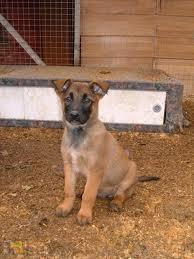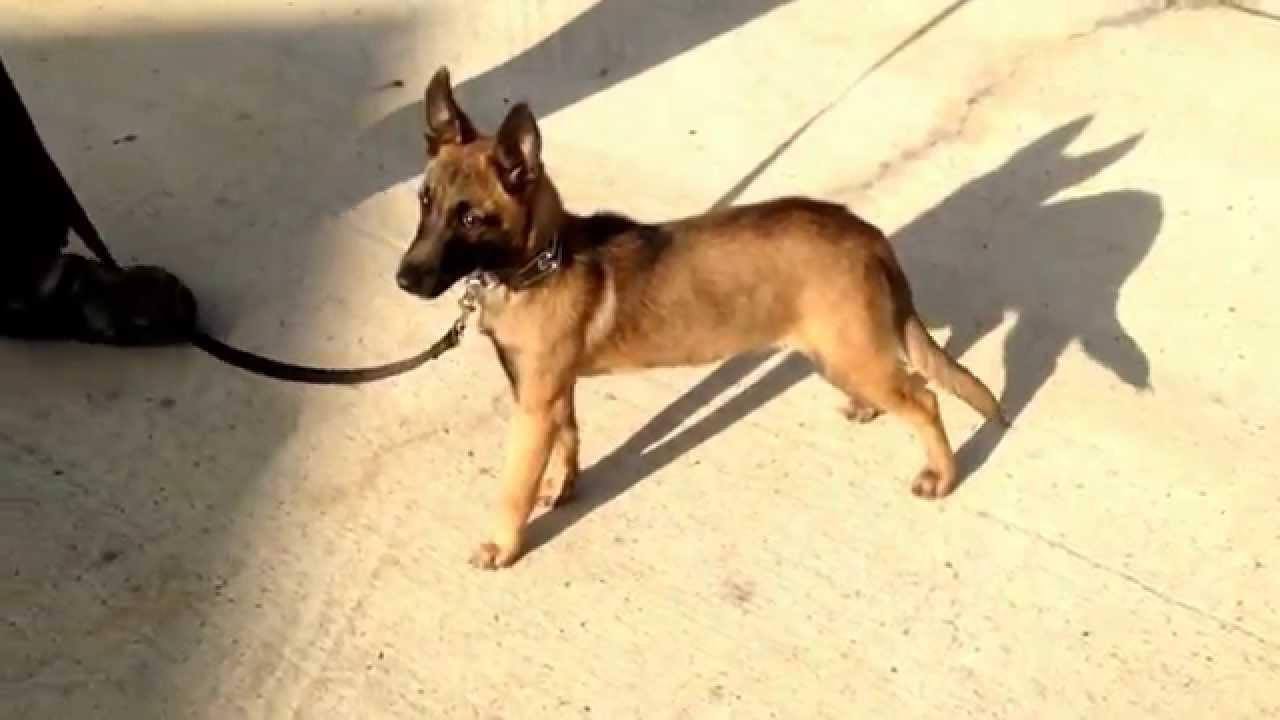The first image is the image on the left, the second image is the image on the right. Assess this claim about the two images: "One image shows a standing dog wearing a leash, and the other shows a dog sitting upright.". Correct or not? Answer yes or no. Yes. The first image is the image on the left, the second image is the image on the right. Assess this claim about the two images: "The dog in the image on the left is wearing a leash.". Correct or not? Answer yes or no. No. The first image is the image on the left, the second image is the image on the right. For the images shown, is this caption "The dog in the image on the left is on a leash." true? Answer yes or no. No. The first image is the image on the left, the second image is the image on the right. Examine the images to the left and right. Is the description "A dog is standing on all fours on a hard surface and wears a leash." accurate? Answer yes or no. Yes. 